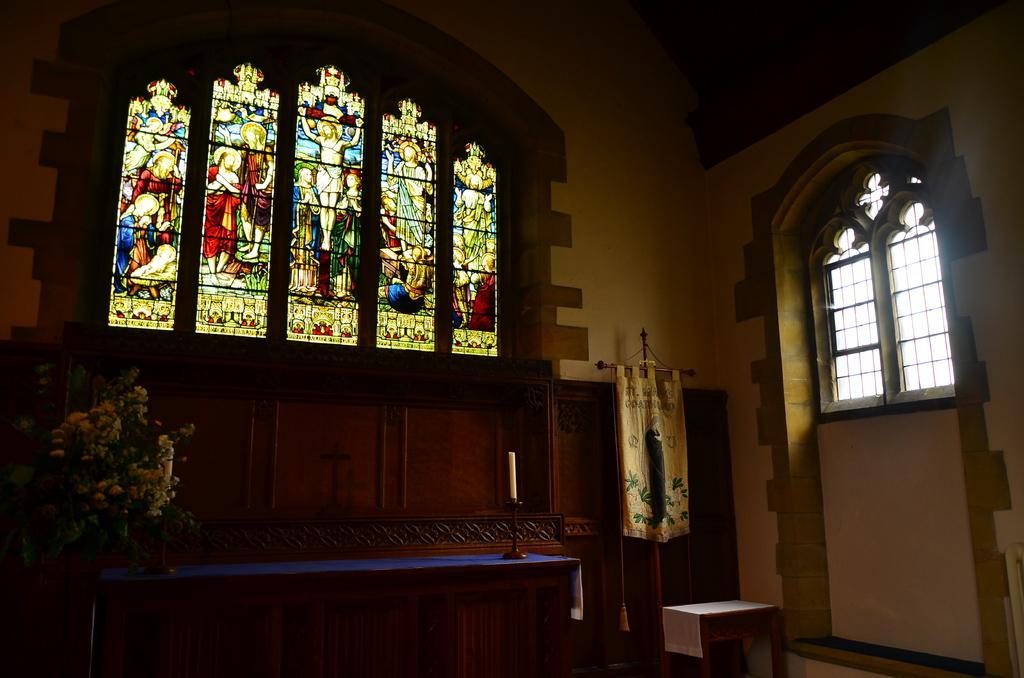Can you describe this image briefly? In this picture there is a inside view of church. In the front there is a window with Jesus Christ photo frames and on the right side there is a window. In the front we can see the a wooden panel wall and table with flower pot and a candle. 